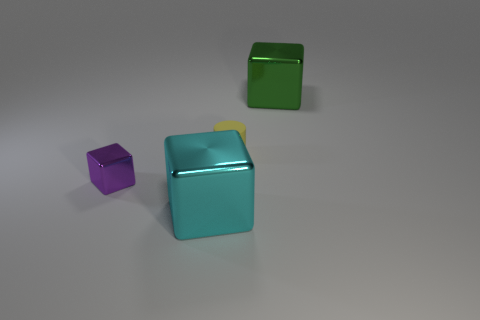Are there any purple metal cubes right of the small yellow matte cylinder?
Your answer should be very brief. No. What number of other objects are the same shape as the large green metallic thing?
Your answer should be compact. 2. There is a metal cube that is the same size as the matte cylinder; what color is it?
Give a very brief answer. Purple. Is the number of large green blocks in front of the cyan shiny object less than the number of purple things that are in front of the tiny shiny thing?
Provide a succinct answer. No. What number of tiny shiny cubes are left of the large thing in front of the thing to the right of the tiny rubber cylinder?
Make the answer very short. 1. There is a cyan thing that is the same shape as the purple metallic object; what is its size?
Your response must be concise. Large. Are there any other things that are the same size as the purple metallic cube?
Offer a very short reply. Yes. Are there fewer cyan metallic objects behind the tiny purple metallic thing than tiny cylinders?
Keep it short and to the point. Yes. Is the shape of the yellow matte thing the same as the green object?
Make the answer very short. No. The other tiny object that is the same shape as the cyan object is what color?
Ensure brevity in your answer.  Purple. 